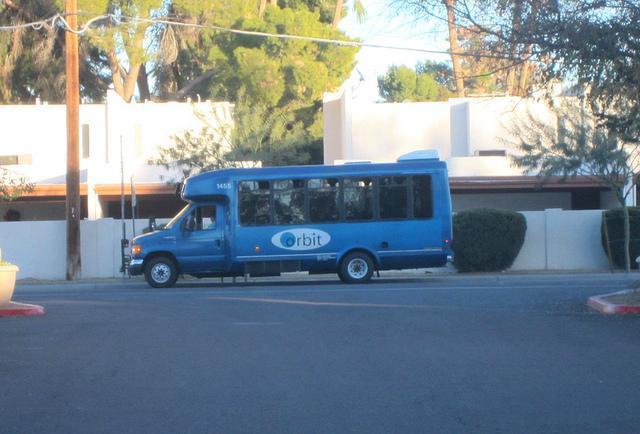How many cakes are pink?
Give a very brief answer. 0. 